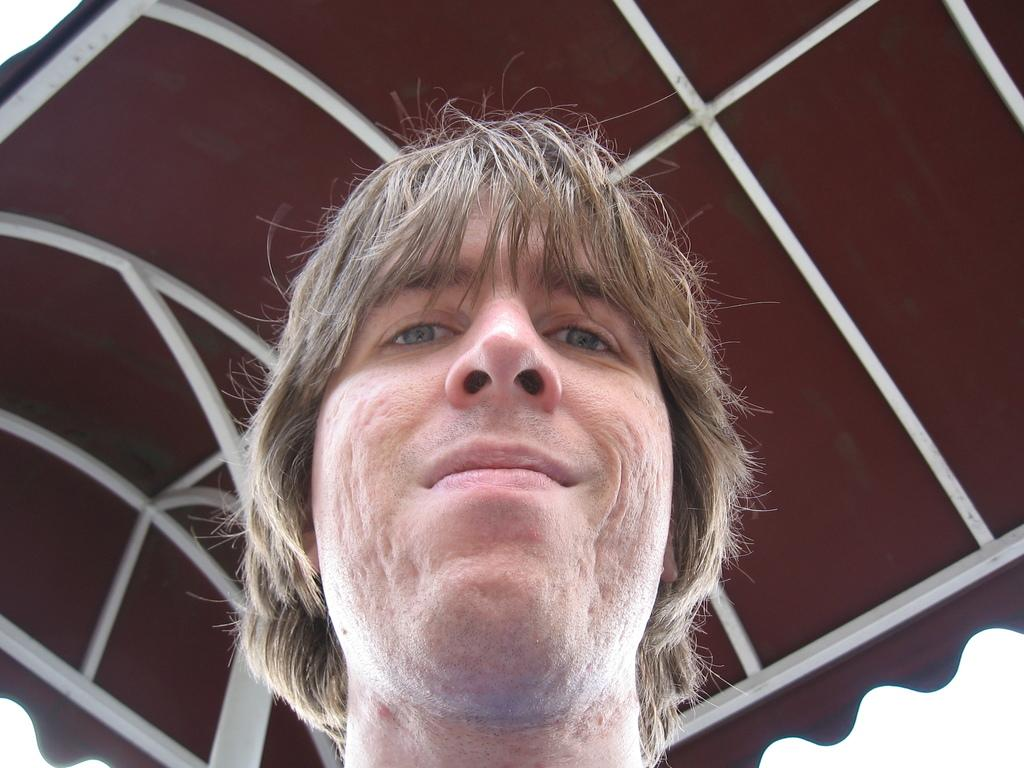What is the main subject of the image? There is a person's face in the image. What can be seen at the top of the image? There is a roof at the top of the image. What type of branch can be seen growing from the person's face in the image? There is no branch growing from the person's face in the image. Is it raining in the image? The provided facts do not mention any rain in the image. Which direction is the person's face facing in the image? The provided facts do not specify the direction the person's face is facing in the image. 